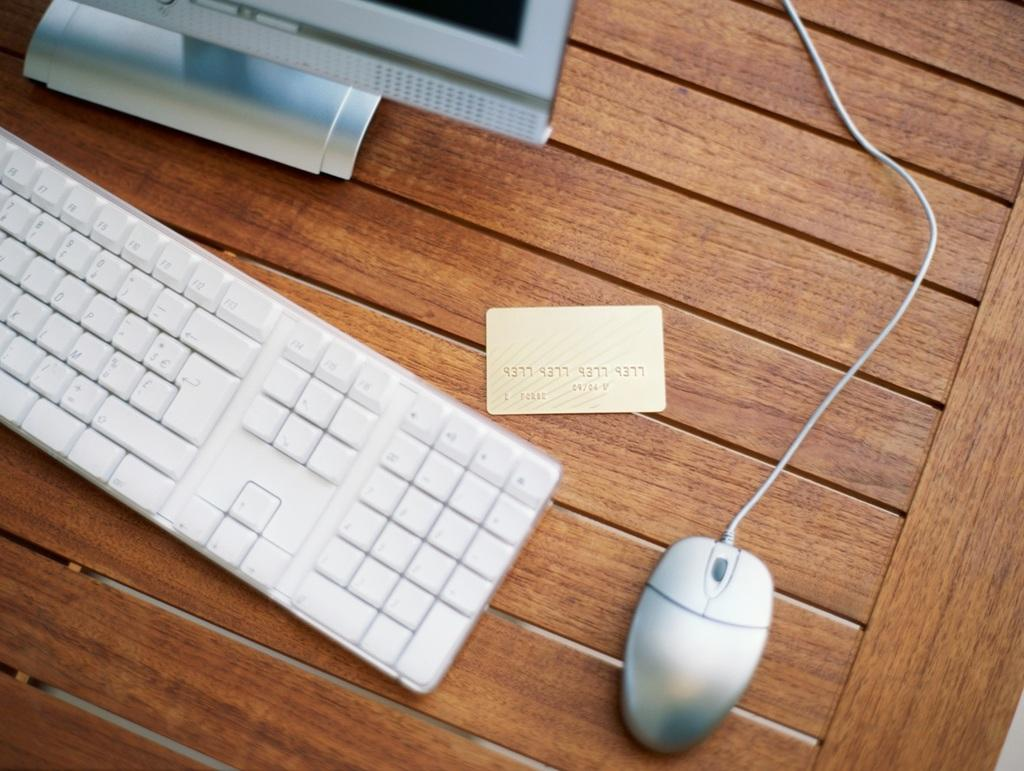What is the main subject of the image? The main subject of the image is a system. What input device is visible in the image? There is a keyboard in the image. What pointing device is visible in the image? There is a mouse in the image. What type of object is present in the image that is not an input device? There is a card in the image. What is the color of the surface the objects are on? The surface the objects are on is brown in color. How does the system adjust the cap of the army in the image? There is no cap or army present in the image; the image features a system, keyboard, mouse, card, and a brown surface. 